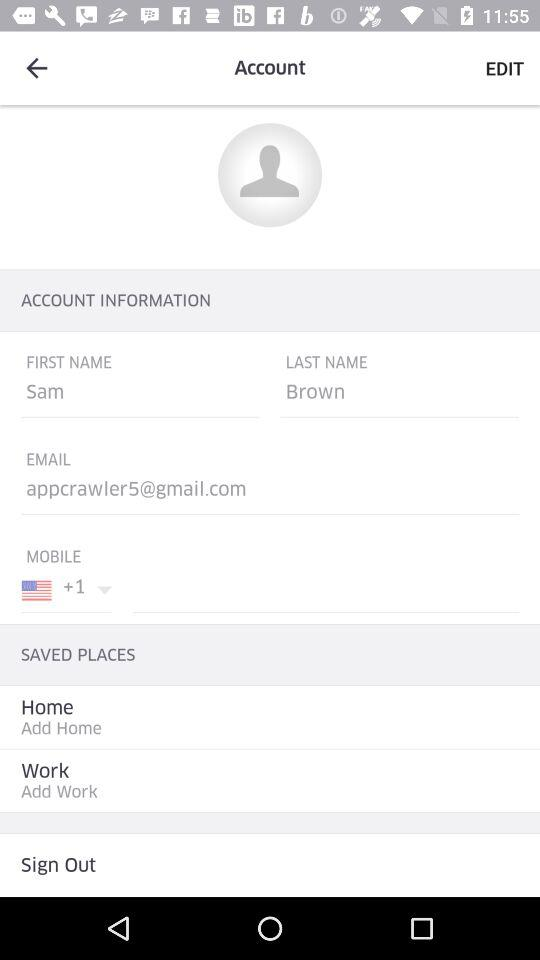What is the country code? The country code is +1. 